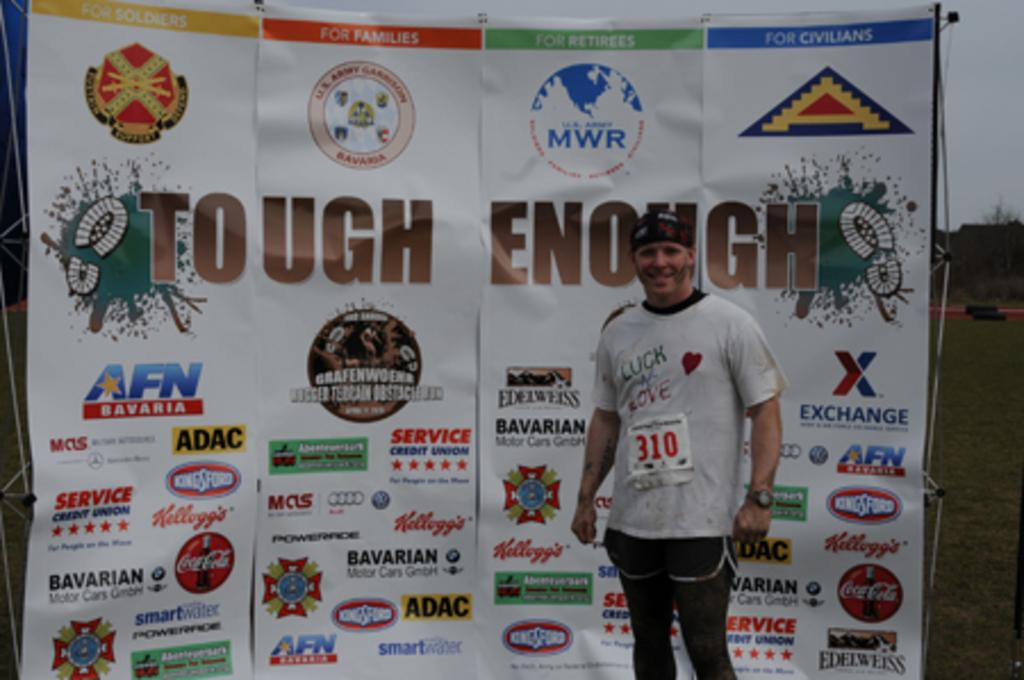<image>
Write a terse but informative summary of the picture. a man next to a sign that says tough on it 